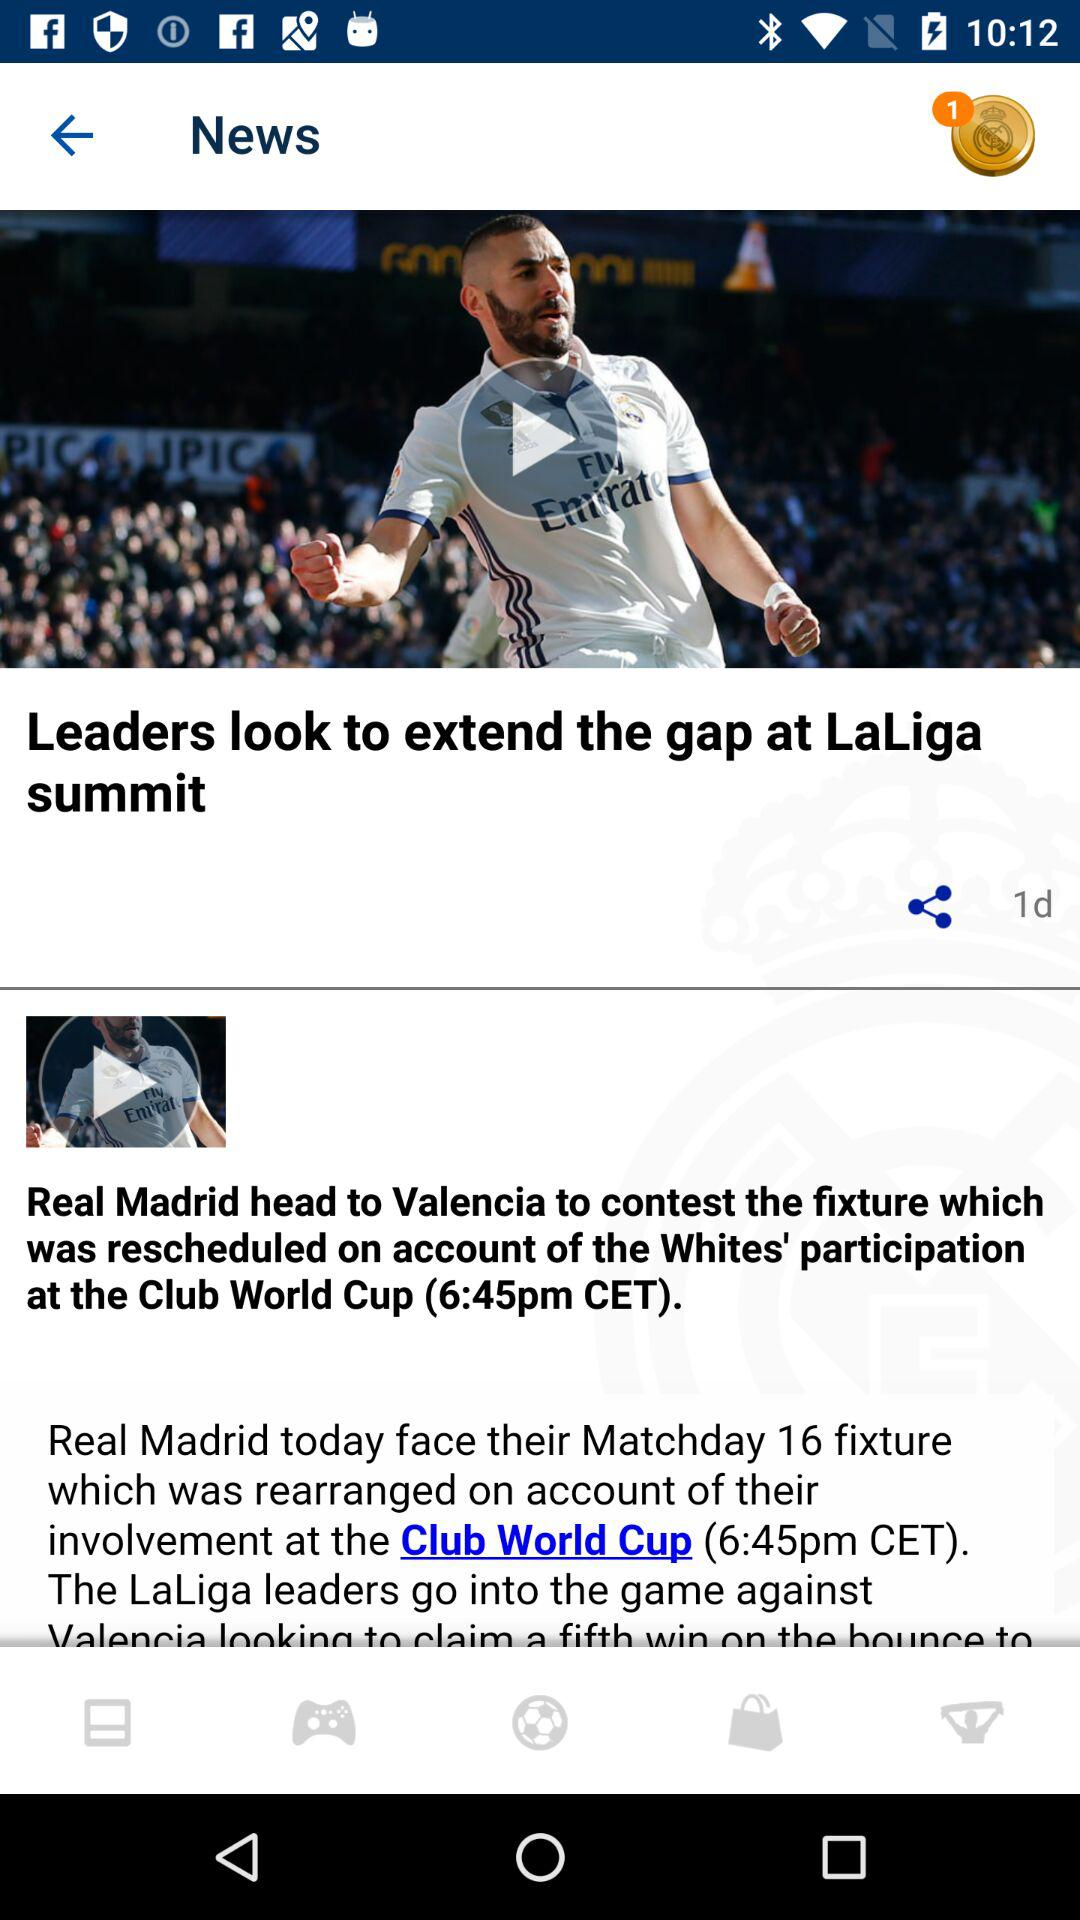How many notifications are there? There is 1 notification. 